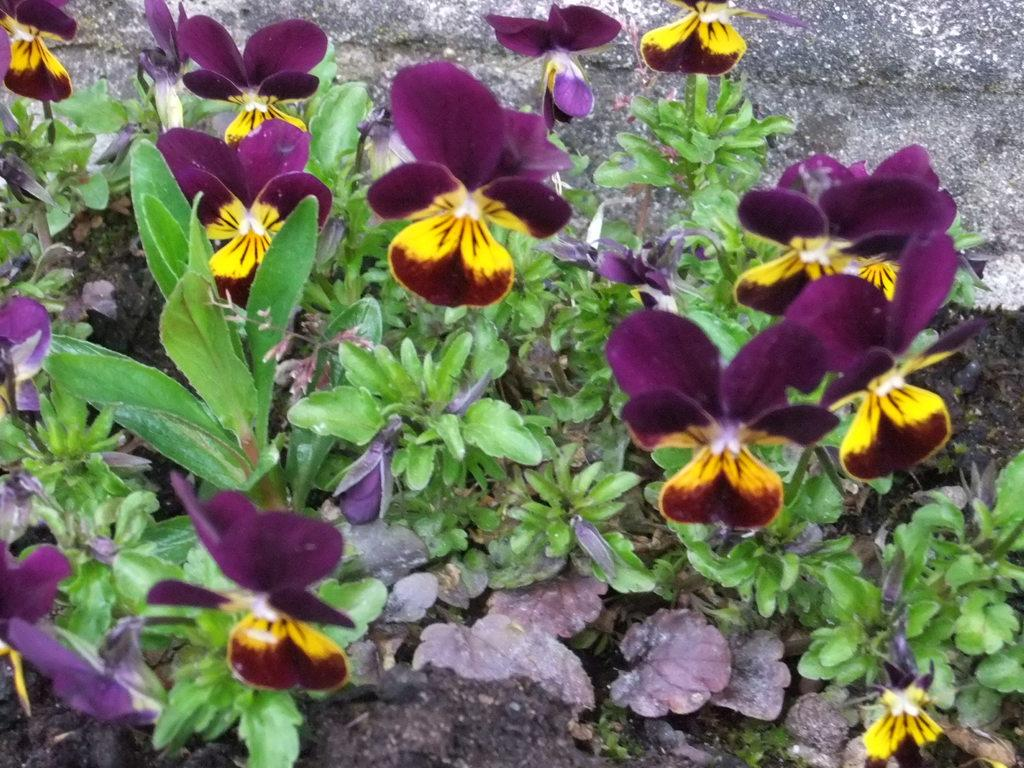What type of plants are present in the image? There are plants with flowers in the image. What is at the base of the plants in the image? There is soil at the bottom of the image. What type of material can be seen in the background of the image? There is stone visible in the background of the image. What type of cabbage is being used as a hat in the image? There is no cabbage or hat present in the image. 